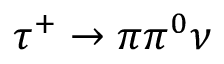Convert formula to latex. <formula><loc_0><loc_0><loc_500><loc_500>\tau ^ { + } \to \pi \pi ^ { 0 } \nu</formula> 